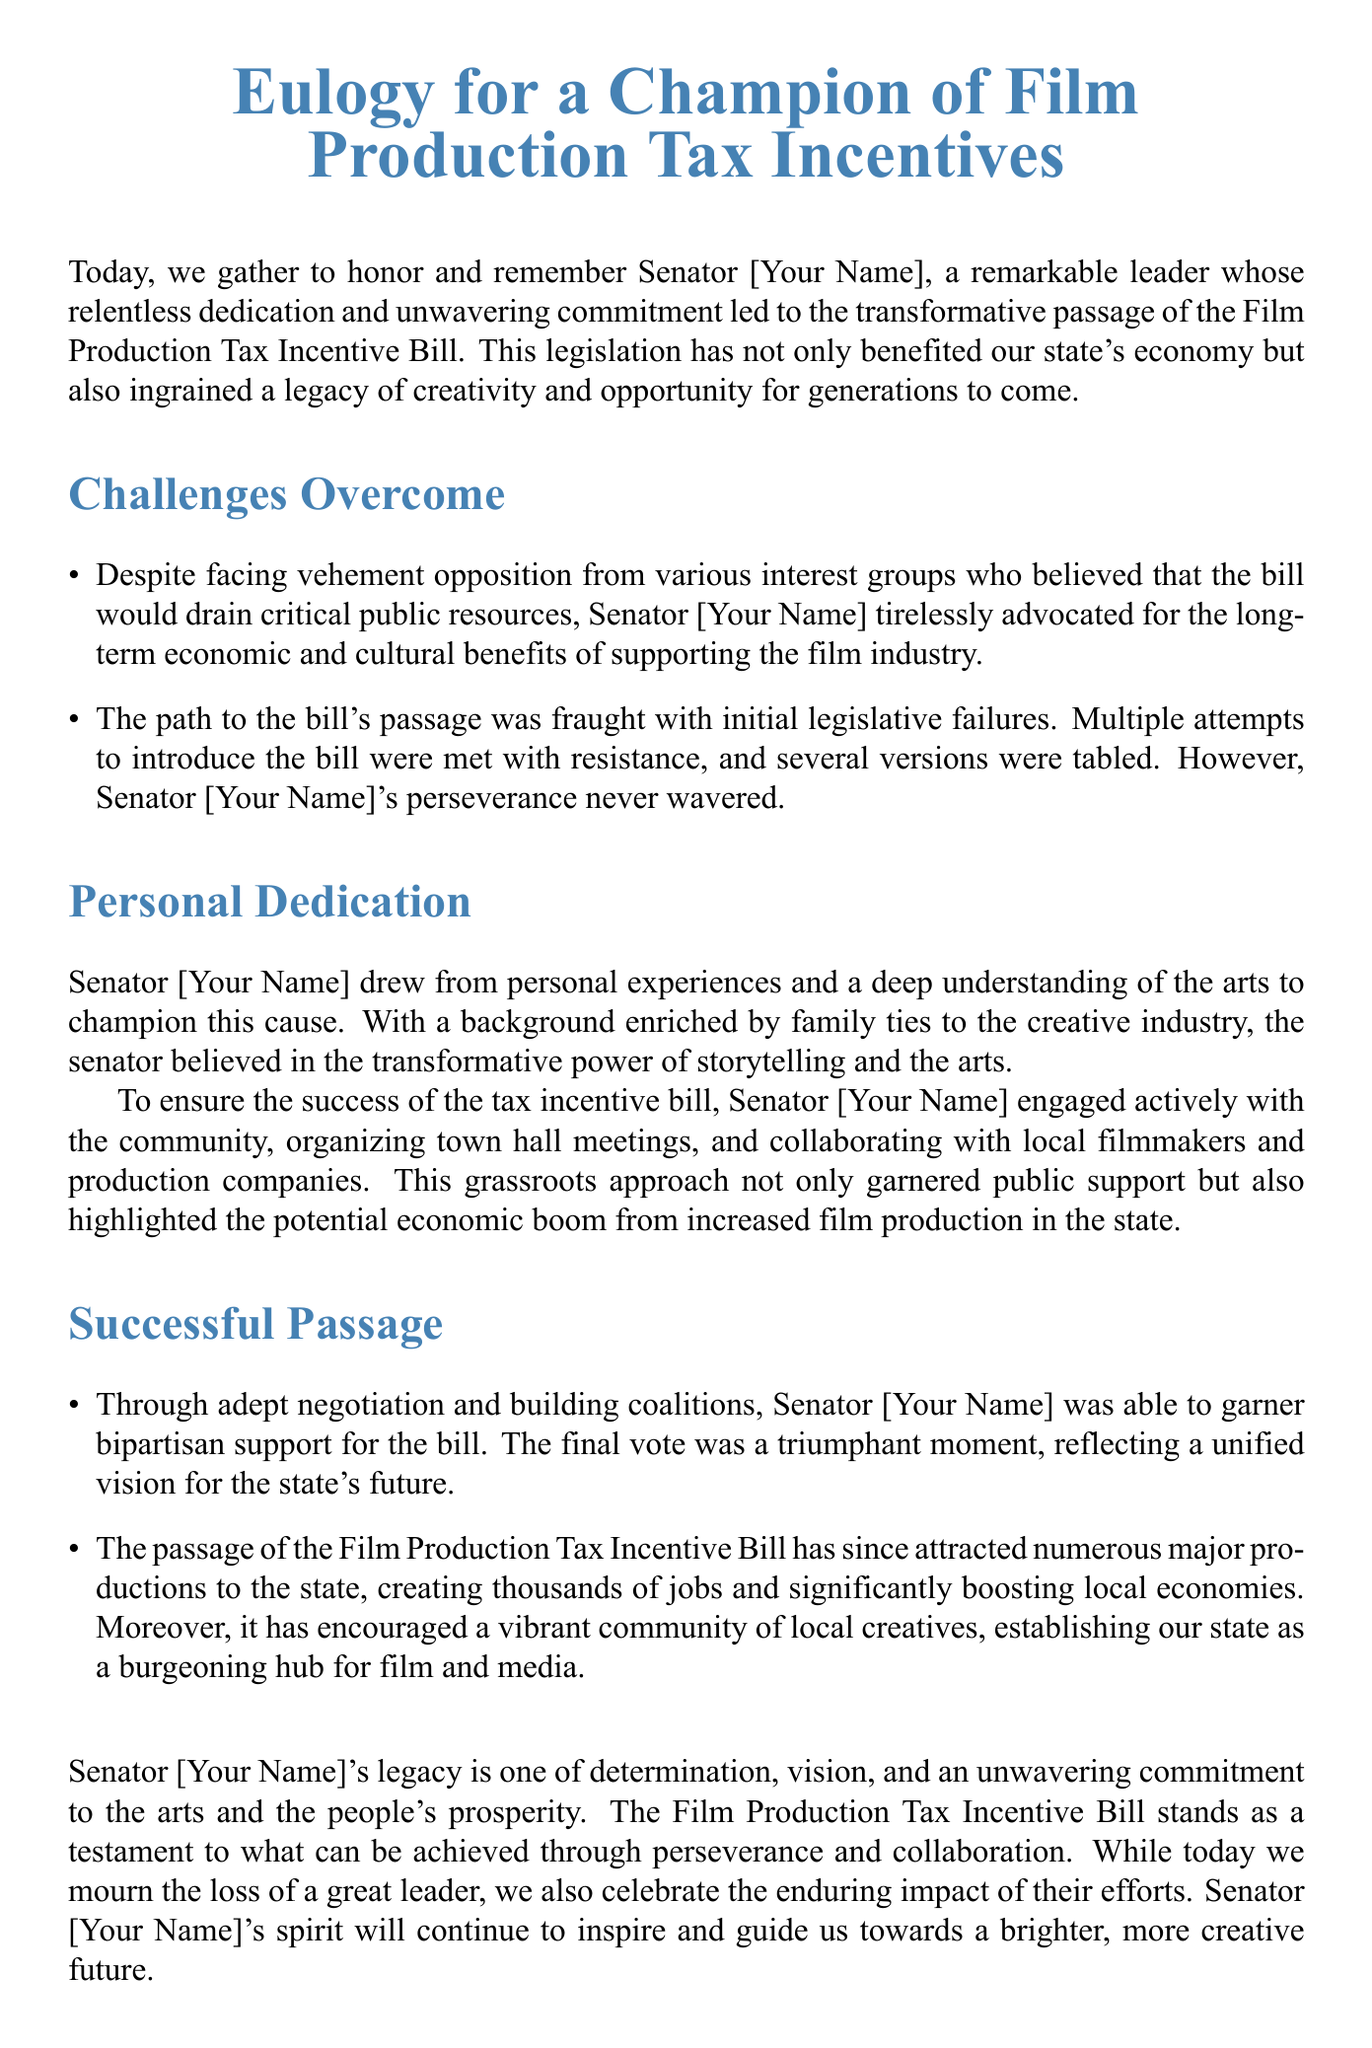What is the title of the document? The title of the document is presented prominently at the beginning.
Answer: Eulogy for a Champion of Film Production Tax Incentives Who is the main subject of the eulogy? The eulogy honors and remembers a specific individual.
Answer: Senator [Your Name] What was the name of the legislation discussed? The legislation that was successfully passed is mentioned explicitly in the document.
Answer: Film Production Tax Incentive Bill What challenges did the senator face? Specific challenges overcome by the senator are listed in the document.
Answer: Opposition from interest groups What type of approach did the senator take to engage the community? The document describes how the senator involved the public in the legislative process.
Answer: Grassroots approach What was the outcome of the legislation? The document outlines the effects of the bill after its passage.
Answer: Created thousands of jobs What did the senator's legacy emphasize? The document states what the senator's contributions focused on, reflecting their values.
Answer: Determination and vision How did the senator ensure bipartisan support? The passage described how the senator worked to unite different political groups.
Answer: Adept negotiation and building coalitions What did the bill ultimately establish for the state? The successful passage of the bill led to a significant outcome for the state's creativity sector.
Answer: A burgeoning hub for film and media 